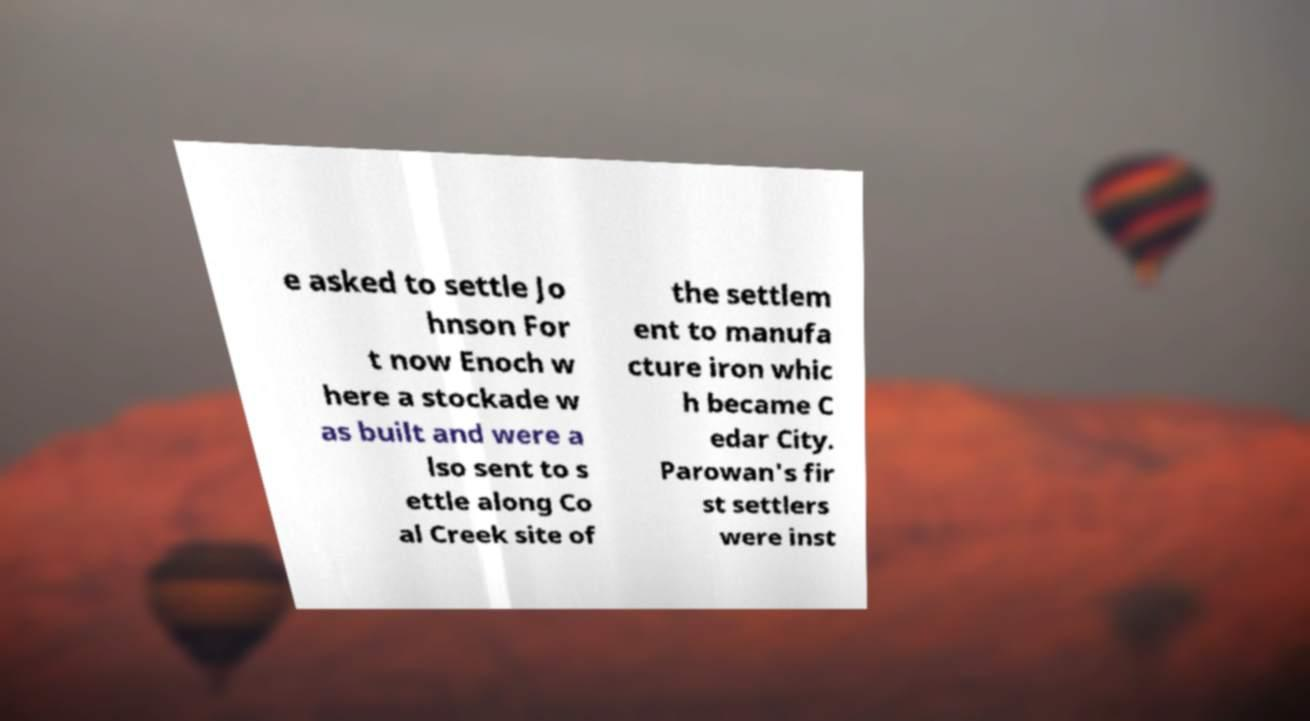Please read and relay the text visible in this image. What does it say? e asked to settle Jo hnson For t now Enoch w here a stockade w as built and were a lso sent to s ettle along Co al Creek site of the settlem ent to manufa cture iron whic h became C edar City. Parowan's fir st settlers were inst 